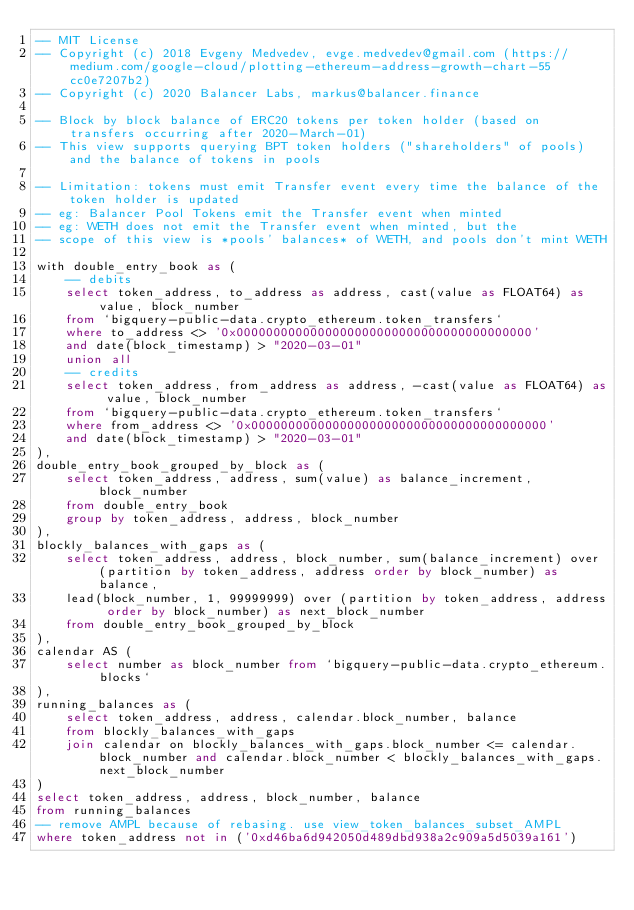<code> <loc_0><loc_0><loc_500><loc_500><_SQL_>-- MIT License
-- Copyright (c) 2018 Evgeny Medvedev, evge.medvedev@gmail.com (https://medium.com/google-cloud/plotting-ethereum-address-growth-chart-55cc0e7207b2)
-- Copyright (c) 2020 Balancer Labs, markus@balancer.finance

-- Block by block balance of ERC20 tokens per token holder (based on transfers occurring after 2020-March-01)
-- This view supports querying BPT token holders ("shareholders" of pools) and the balance of tokens in pools

-- Limitation: tokens must emit Transfer event every time the balance of the token holder is updated
-- eg: Balancer Pool Tokens emit the Transfer event when minted
-- eg: WETH does not emit the Transfer event when minted, but the 
-- scope of this view is *pools' balances* of WETH, and pools don't mint WETH

with double_entry_book as (
    -- debits
    select token_address, to_address as address, cast(value as FLOAT64) as value, block_number
    from `bigquery-public-data.crypto_ethereum.token_transfers`
    where to_address <> '0x0000000000000000000000000000000000000000' 
    and date(block_timestamp) > "2020-03-01" 
    union all
    -- credits
    select token_address, from_address as address, -cast(value as FLOAT64) as value, block_number
    from `bigquery-public-data.crypto_ethereum.token_transfers`
    where from_address <> '0x0000000000000000000000000000000000000000' 
    and date(block_timestamp) > "2020-03-01" 
),
double_entry_book_grouped_by_block as (
    select token_address, address, sum(value) as balance_increment, block_number
    from double_entry_book
    group by token_address, address, block_number
),
blockly_balances_with_gaps as (
    select token_address, address, block_number, sum(balance_increment) over (partition by token_address, address order by block_number) as balance,
    lead(block_number, 1, 99999999) over (partition by token_address, address order by block_number) as next_block_number
    from double_entry_book_grouped_by_block
),
calendar AS (
    select number as block_number from `bigquery-public-data.crypto_ethereum.blocks`
),
running_balances as (
    select token_address, address, calendar.block_number, balance
    from blockly_balances_with_gaps
    join calendar on blockly_balances_with_gaps.block_number <= calendar.block_number and calendar.block_number < blockly_balances_with_gaps.next_block_number
)
select token_address, address, block_number, balance
from running_balances
-- remove AMPL because of rebasing. use view_token_balances_subset_AMPL
where token_address not in ('0xd46ba6d942050d489dbd938a2c909a5d5039a161')</code> 